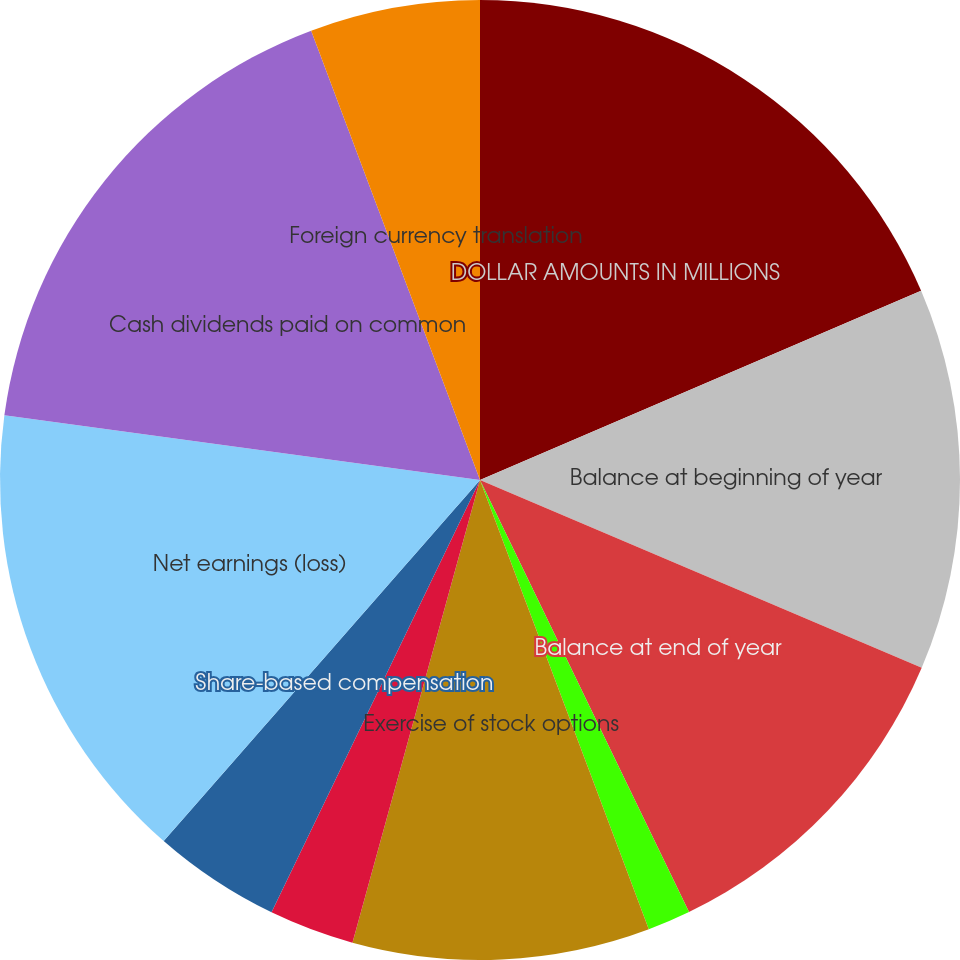Convert chart to OTSL. <chart><loc_0><loc_0><loc_500><loc_500><pie_chart><fcel>DOLLAR AMOUNTS IN MILLIONS<fcel>Balance at beginning of year<fcel>Balance at end of year<fcel>Retraction or redemption<fcel>Exercise of stock options<fcel>Retraction or redemption of<fcel>Share-based compensation<fcel>Net earnings (loss)<fcel>Cash dividends paid on common<fcel>Foreign currency translation<nl><fcel>18.55%<fcel>12.85%<fcel>11.43%<fcel>1.45%<fcel>10.0%<fcel>2.87%<fcel>4.3%<fcel>15.7%<fcel>17.13%<fcel>5.72%<nl></chart> 